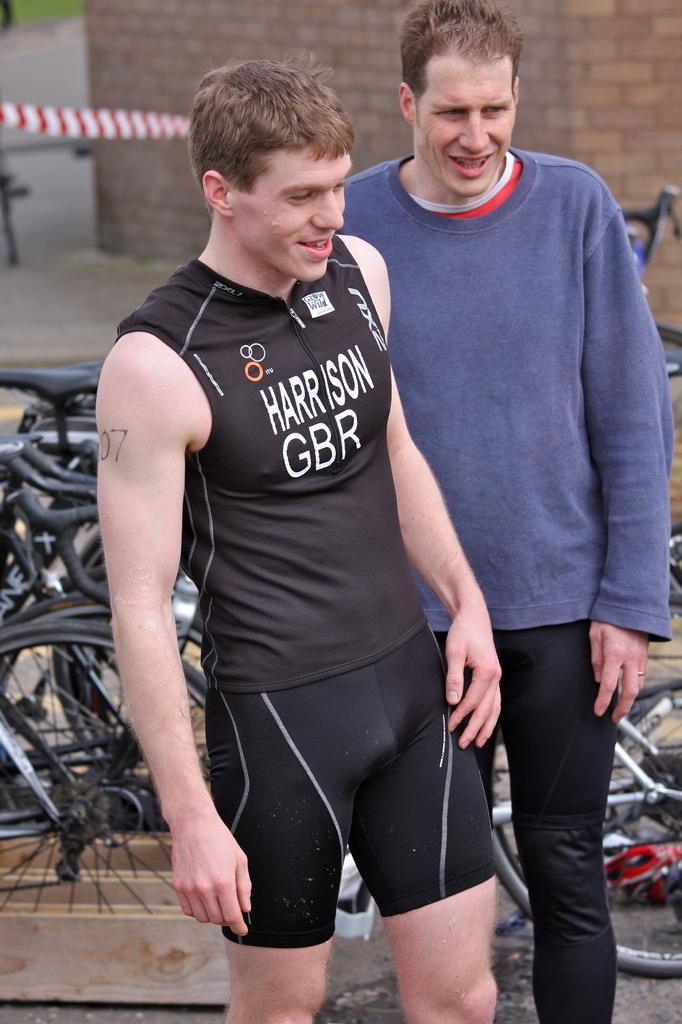<image>
Summarize the visual content of the image. A male marathoner representing Great Britain is standing with another man in front of bicycles. 